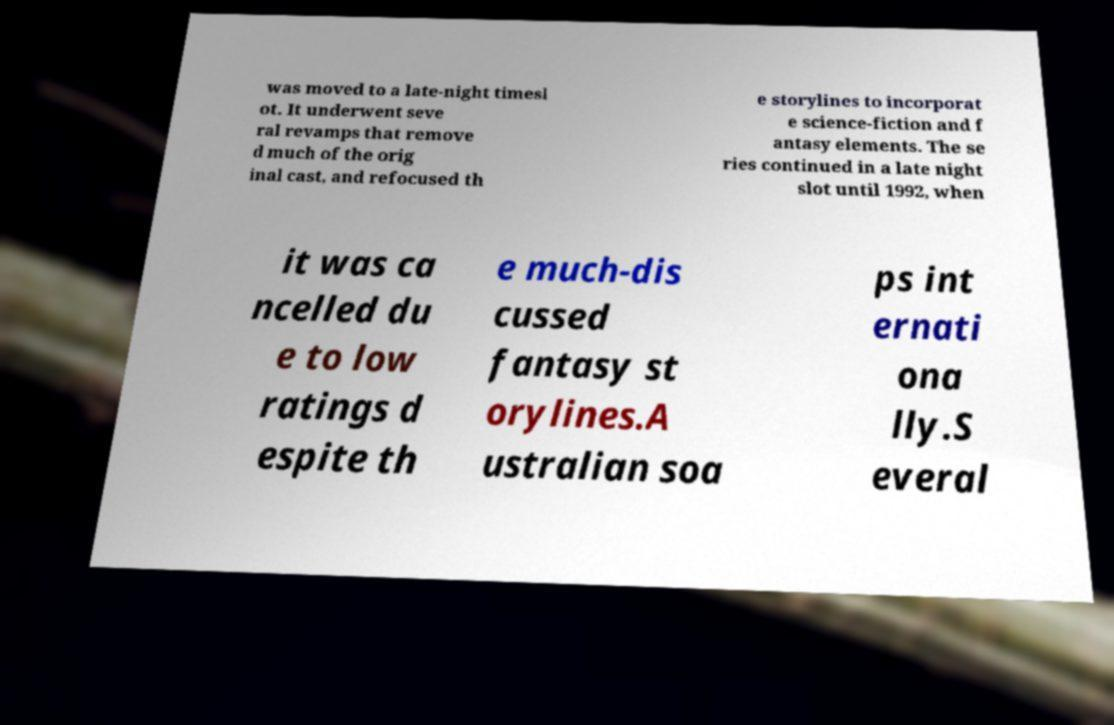Could you extract and type out the text from this image? was moved to a late-night timesl ot. It underwent seve ral revamps that remove d much of the orig inal cast, and refocused th e storylines to incorporat e science-fiction and f antasy elements. The se ries continued in a late night slot until 1992, when it was ca ncelled du e to low ratings d espite th e much-dis cussed fantasy st orylines.A ustralian soa ps int ernati ona lly.S everal 